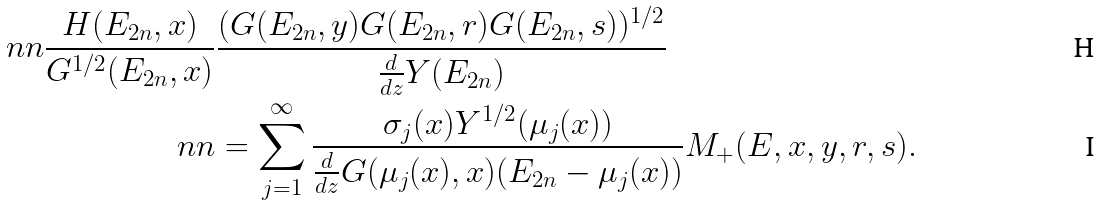Convert formula to latex. <formula><loc_0><loc_0><loc_500><loc_500>\ n n \frac { H ( E _ { 2 n } , x ) } { G ^ { 1 / 2 } ( E _ { 2 n } , x ) } & \frac { ( G ( E _ { 2 n } , y ) G ( E _ { 2 n } , r ) G ( E _ { 2 n } , s ) ) ^ { 1 / 2 } } { \frac { d } { d z } Y ( E _ { 2 n } ) } \\ \ n n & = \sum _ { j = 1 } ^ { \infty } \frac { \sigma _ { j } ( x ) Y ^ { 1 / 2 } ( \mu _ { j } ( x ) ) } { \frac { d } { d z } G ( \mu _ { j } ( x ) , x ) ( E _ { 2 n } - \mu _ { j } ( x ) ) } M _ { + } ( E , x , y , r , s ) .</formula> 